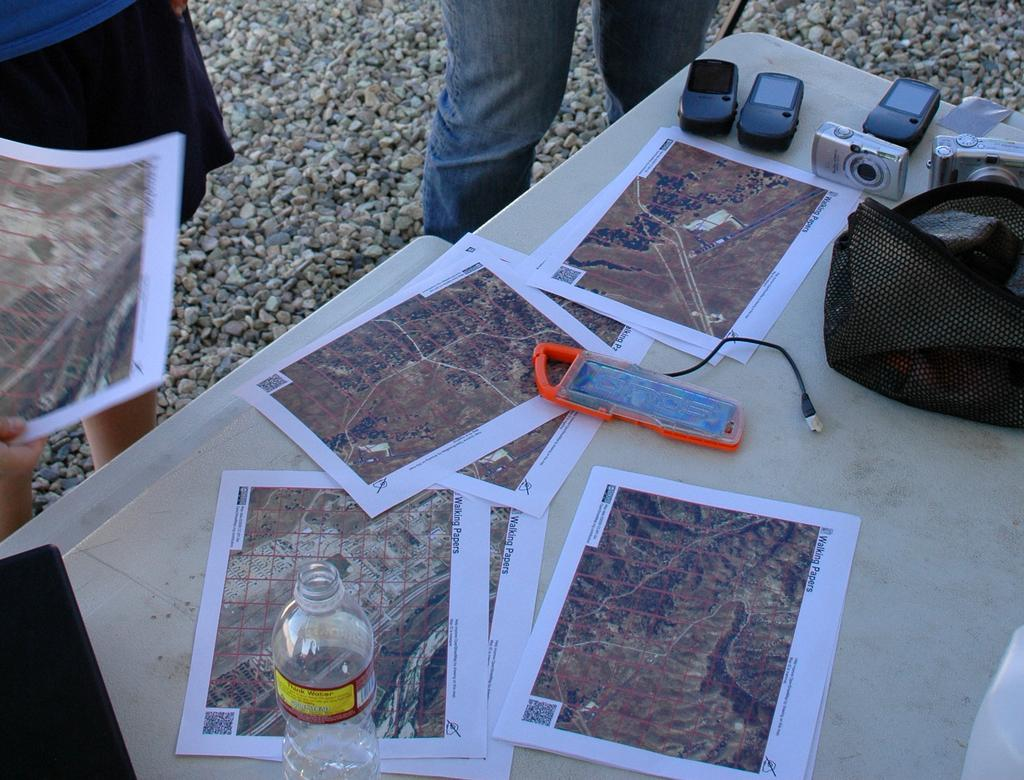What type of furniture is present in the image? There is a table in the image. What items can be seen on the table? Papers, bottles, torch lights, and cameras are on the table. Can you describe the purpose of the items on the table? The papers may be for writing or reading, the bottles could contain liquids, the torch lights might provide illumination, and the cameras could be used for capturing images. What type of cream is being spread on the papers in the image? There is no cream present in the image, and the papers are not being used for spreading any substance. 